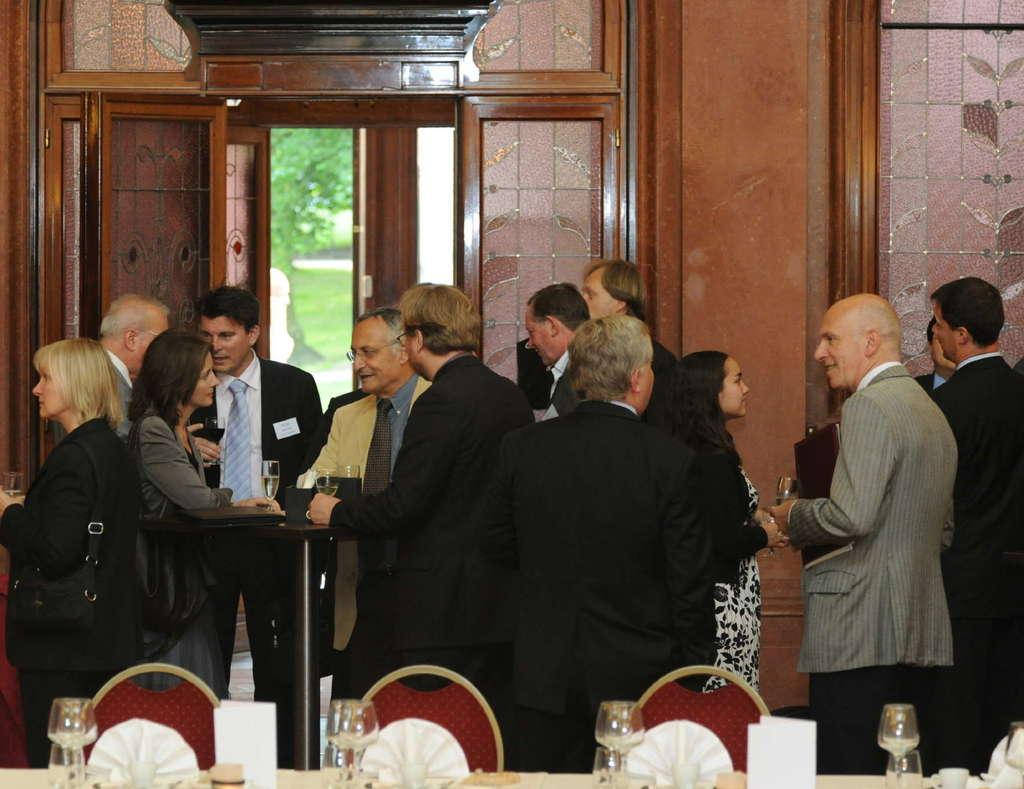How many people are in the image? There is a group of people in the image, but the exact number cannot be determined from the provided facts. What type of furniture is present in the image? There are tables and chairs in the image. What objects are used for drinking in the image? There are glasses in the image. What can be seen in the background of the image? There is a wall, doors, and trees in the background of the image. What type of noise can be heard coming from the plant in the image? There is no plant present in the image, and therefore no noise can be heard from it. What type of cart is visible in the image? There is no cart present in the image. 